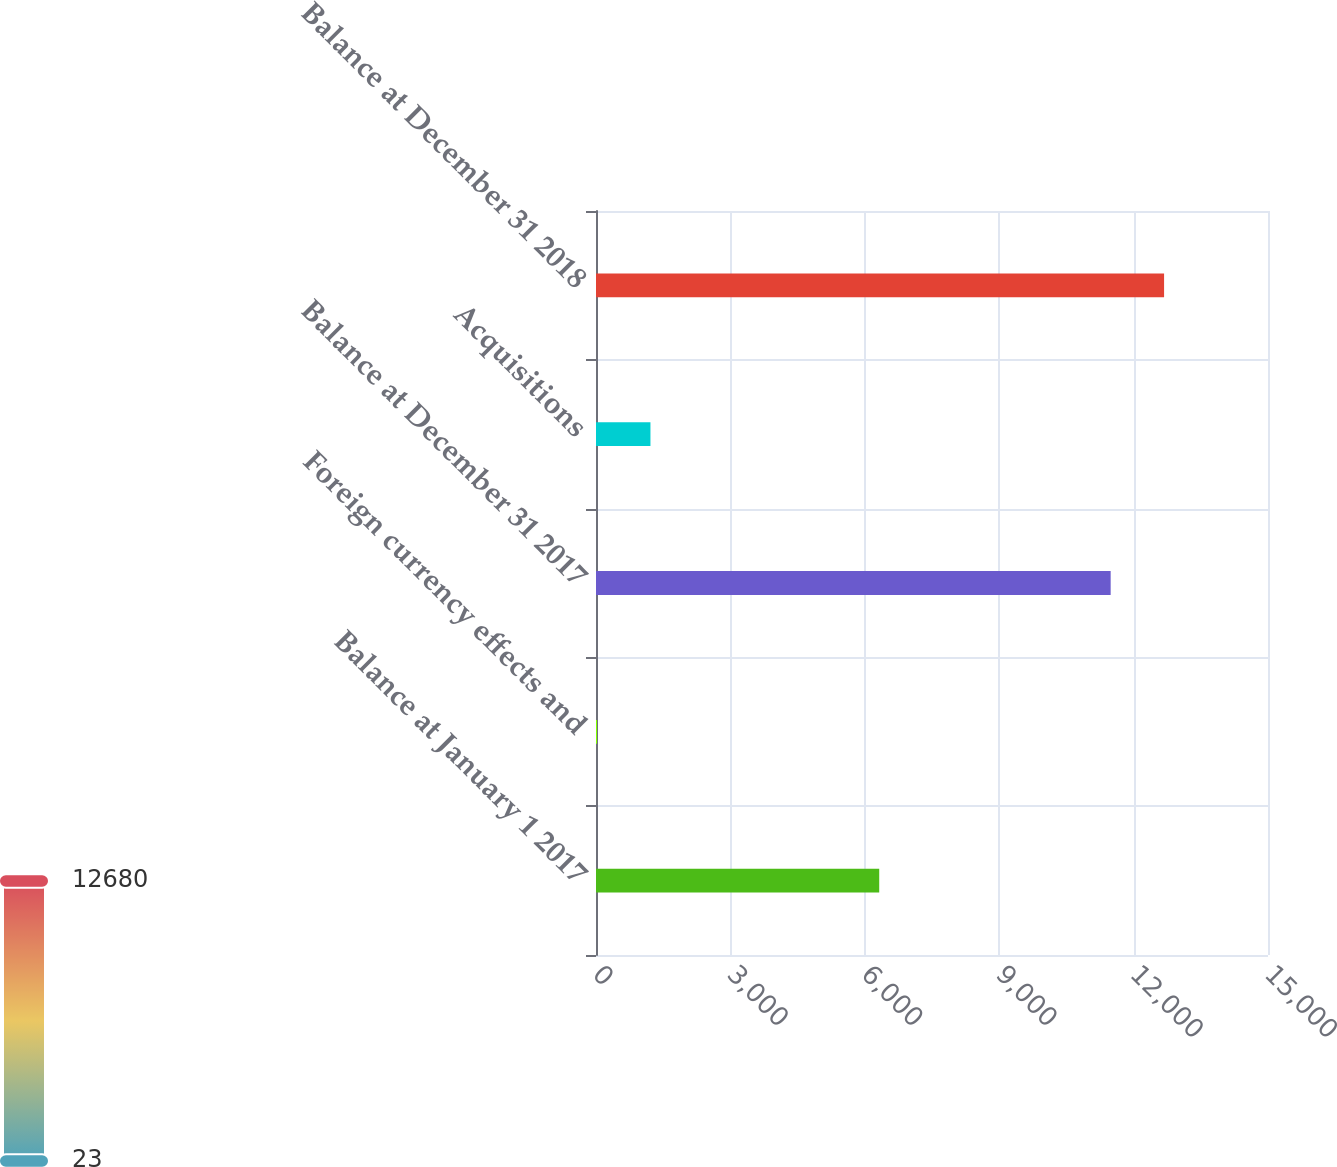<chart> <loc_0><loc_0><loc_500><loc_500><bar_chart><fcel>Balance at January 1 2017<fcel>Foreign currency effects and<fcel>Balance at December 31 2017<fcel>Acquisitions<fcel>Balance at December 31 2018<nl><fcel>6322<fcel>23<fcel>11488<fcel>1215.4<fcel>12680.4<nl></chart> 